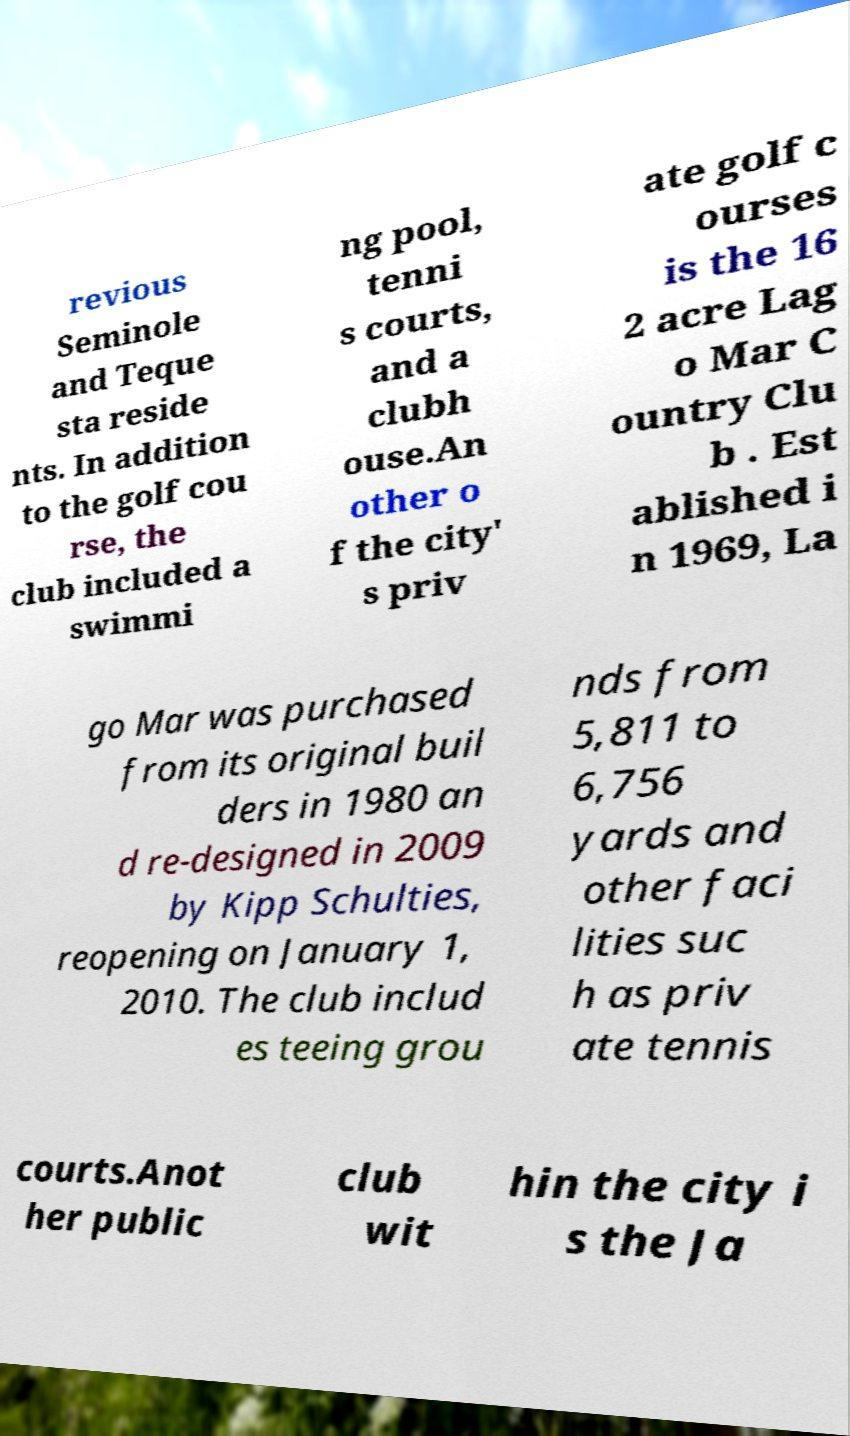Can you accurately transcribe the text from the provided image for me? revious Seminole and Teque sta reside nts. In addition to the golf cou rse, the club included a swimmi ng pool, tenni s courts, and a clubh ouse.An other o f the city' s priv ate golf c ourses is the 16 2 acre Lag o Mar C ountry Clu b . Est ablished i n 1969, La go Mar was purchased from its original buil ders in 1980 an d re-designed in 2009 by Kipp Schulties, reopening on January 1, 2010. The club includ es teeing grou nds from 5,811 to 6,756 yards and other faci lities suc h as priv ate tennis courts.Anot her public club wit hin the city i s the Ja 